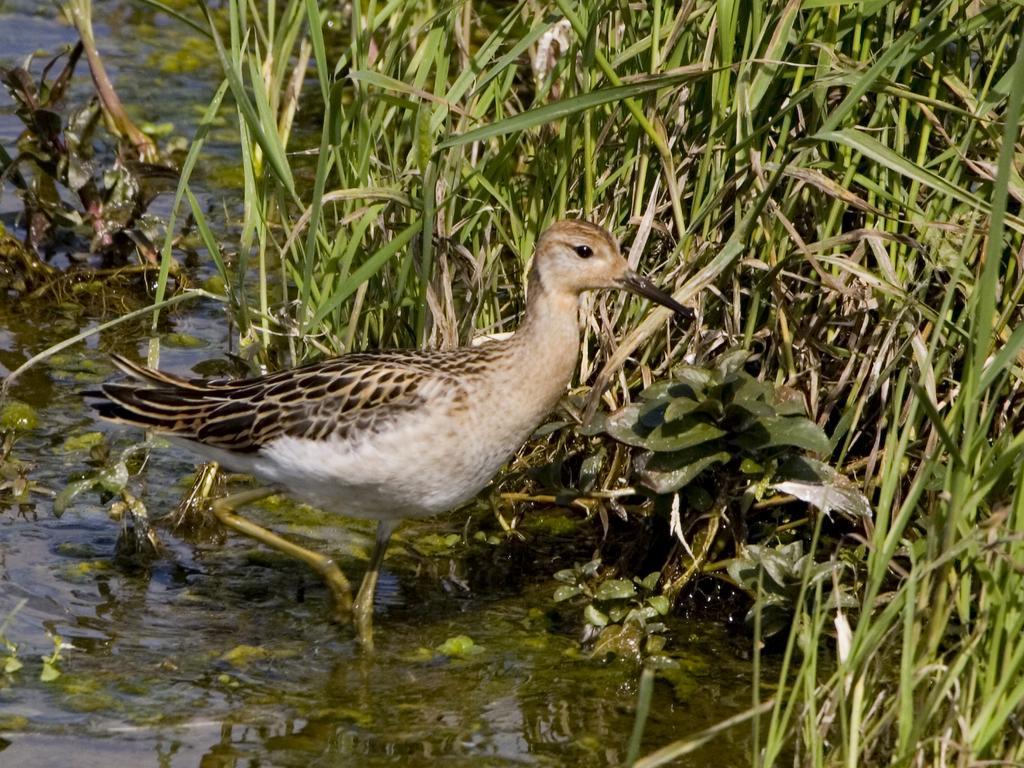Please provide a concise description of this image. In this picture we can see a bird on water and in the background we can see the grass. 